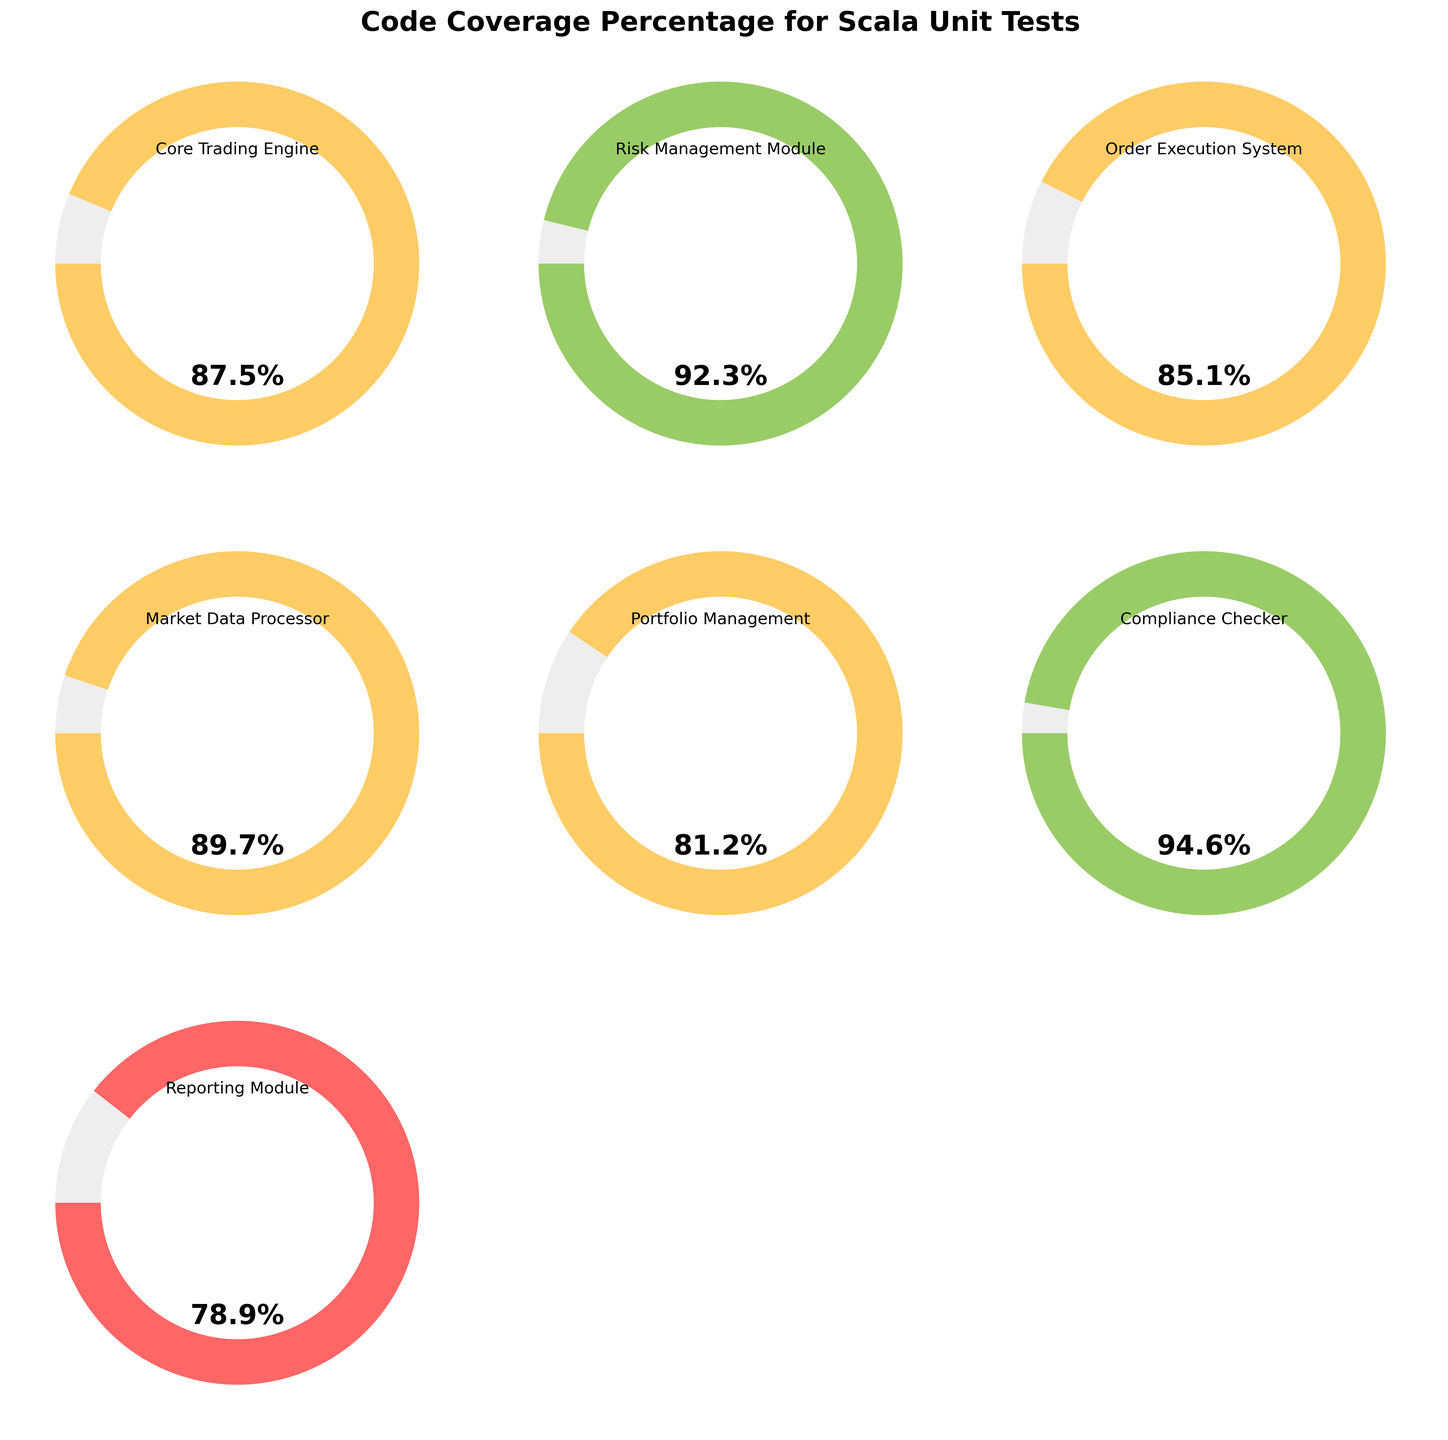What is the title of the figure? The title is the text at the top of the figure that describes what the figure is about. The title of this figure is clearly written at the top in a large, bold font.
Answer: Code Coverage Percentage for Scala Unit Tests Which module has the highest code coverage? Look at the gauge charts and identify the module with the highest percentage displayed. The Compliance Checker module has the highest percentage.
Answer: Compliance Checker What is the code coverage percentage for the Reporting Module? Locate the gauge chart label for the Reporting Module and read the percentage value displayed within that specific gauge. The gauge for the Reporting Module shows 78.9%.
Answer: 78.9% Compare the code coverage of the Core Trading Engine to the Order Execution System. Which one is higher? Find the gauge charts for both the Core Trading Engine and the Order Execution System and compare the percentage values shown. The Core Trading Engine has a coverage of 87.5%, and the Order Execution System has 85.1%. Thus, Core Trading Engine is higher.
Answer: Core Trading Engine Which modules have a code coverage above 90%? Identify all the gauge charts showing a percentage above 90%. The Risk Management Module and the Compliance Checker module have coverage above 90%.
Answer: Risk Management Module, Compliance Checker What is the average code coverage percentage for all modules? Add up all the coverage percentages and then divide by the number of modules (7) to find the average. (87.5 + 92.3 + 85.1 + 89.7 + 81.2 + 94.6 + 78.9) / 7 gives the average.
Answer: 86.2% What is the difference in code coverage between the Market Data Processor and the Portfolio Management module? Subtract the coverage percentage of the Portfolio Management module from that of the Market Data Processor. 89.7 - 81.2 = 8.5.
Answer: 8.5 How many modules have a code coverage between 80% and 90%? Count the number of gauge charts with code coverage values falling in the range of 80% to 90%. There are four such modules: Core Trading Engine, Order Execution System, Market Data Processor, and Portfolio Management.
Answer: 4 Is there any module with less than 80% code coverage? Evaluate all the gauge charts to see if any show a percentage below 80%. None of the modules have coverage less than 80%.
Answer: No 